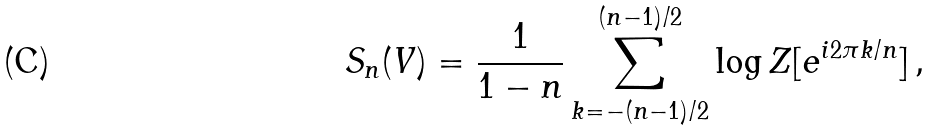Convert formula to latex. <formula><loc_0><loc_0><loc_500><loc_500>S _ { n } ( V ) = \frac { 1 } { 1 - n } \sum _ { k = - ( n - 1 ) / 2 } ^ { ( n - 1 ) / 2 } \log Z [ e ^ { i 2 \pi k / n } ] \, ,</formula> 